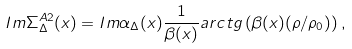Convert formula to latex. <formula><loc_0><loc_0><loc_500><loc_500>I m \Sigma _ { \Delta } ^ { A 2 } ( x ) = I m \alpha _ { \Delta } ( x ) \frac { 1 } { \beta ( x ) } a r c t g \left ( \beta ( x ) ( \rho / \rho _ { 0 } ) \right ) ,</formula> 